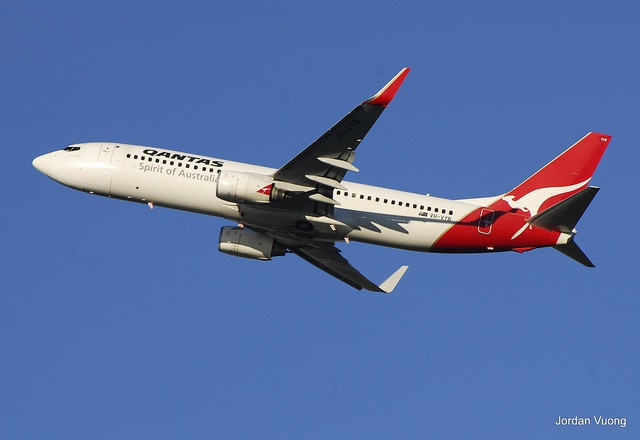Describe the objects in this image and their specific colors. I can see a airplane in blue, black, beige, brown, and gray tones in this image. 